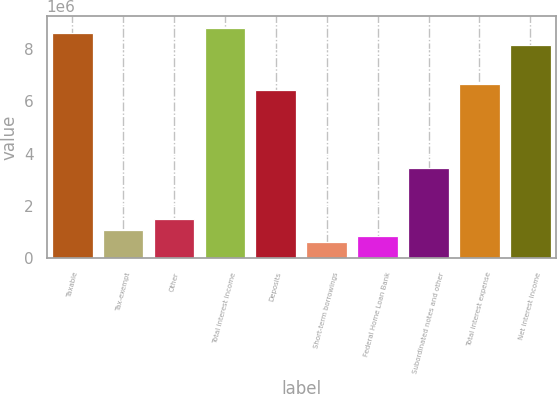<chart> <loc_0><loc_0><loc_500><loc_500><bar_chart><fcel>Taxable<fcel>Tax-exempt<fcel>Other<fcel>Total interest income<fcel>Deposits<fcel>Short-term borrowings<fcel>Federal Home Loan Bank<fcel>Subordinated notes and other<fcel>Total interest expense<fcel>Net interest income<nl><fcel>8.58157e+06<fcel>1.0727e+06<fcel>1.50177e+06<fcel>8.79611e+06<fcel>6.43618e+06<fcel>643618<fcel>858157<fcel>3.43263e+06<fcel>6.65072e+06<fcel>8.15249e+06<nl></chart> 